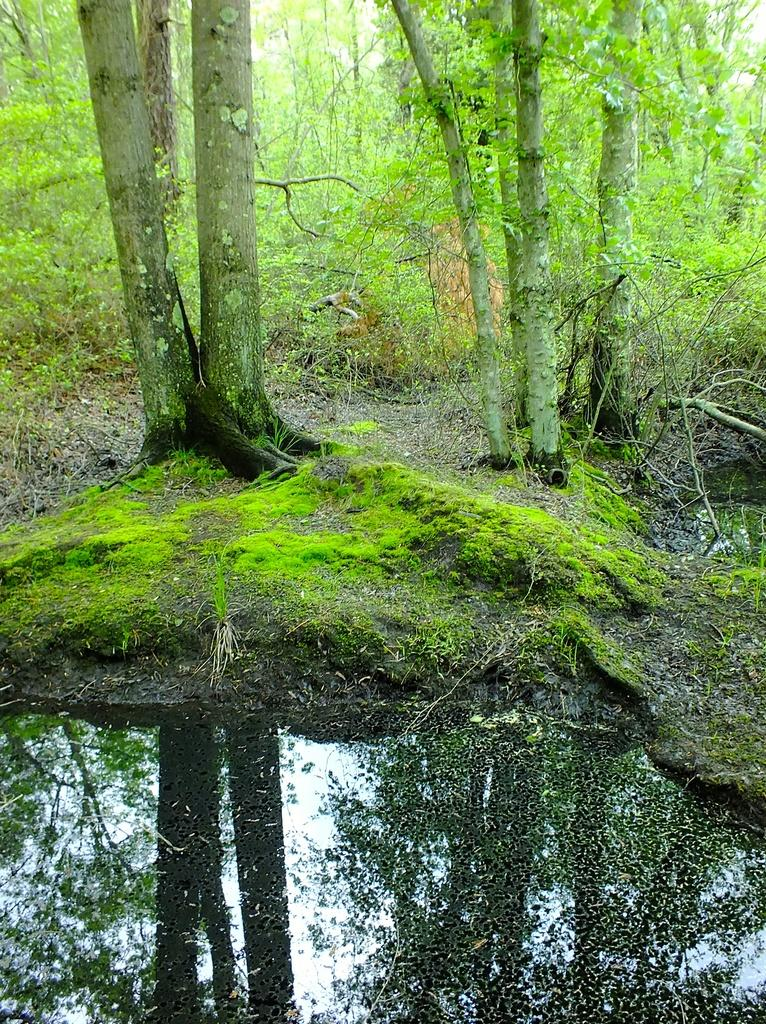What is the primary natural element in the image? There is water in the image. What type of vegetation can be seen in the image? There is grass, plants, and trees in the image. What part of the natural environment is visible in the image? The sky is visible in the image. What type of shoes can be seen in the image? There are no shoes present in the image. 